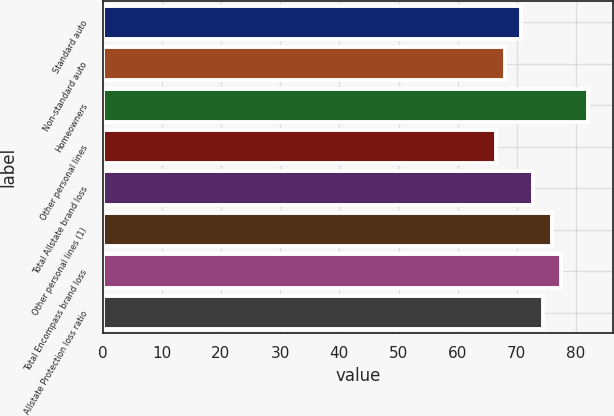Convert chart to OTSL. <chart><loc_0><loc_0><loc_500><loc_500><bar_chart><fcel>Standard auto<fcel>Non-standard auto<fcel>Homeowners<fcel>Other personal lines<fcel>Total Allstate brand loss<fcel>Other personal lines (1)<fcel>Total Encompass brand loss<fcel>Allstate Protection loss ratio<nl><fcel>70.7<fcel>67.97<fcel>82.1<fcel>66.4<fcel>72.8<fcel>75.94<fcel>77.51<fcel>74.37<nl></chart> 